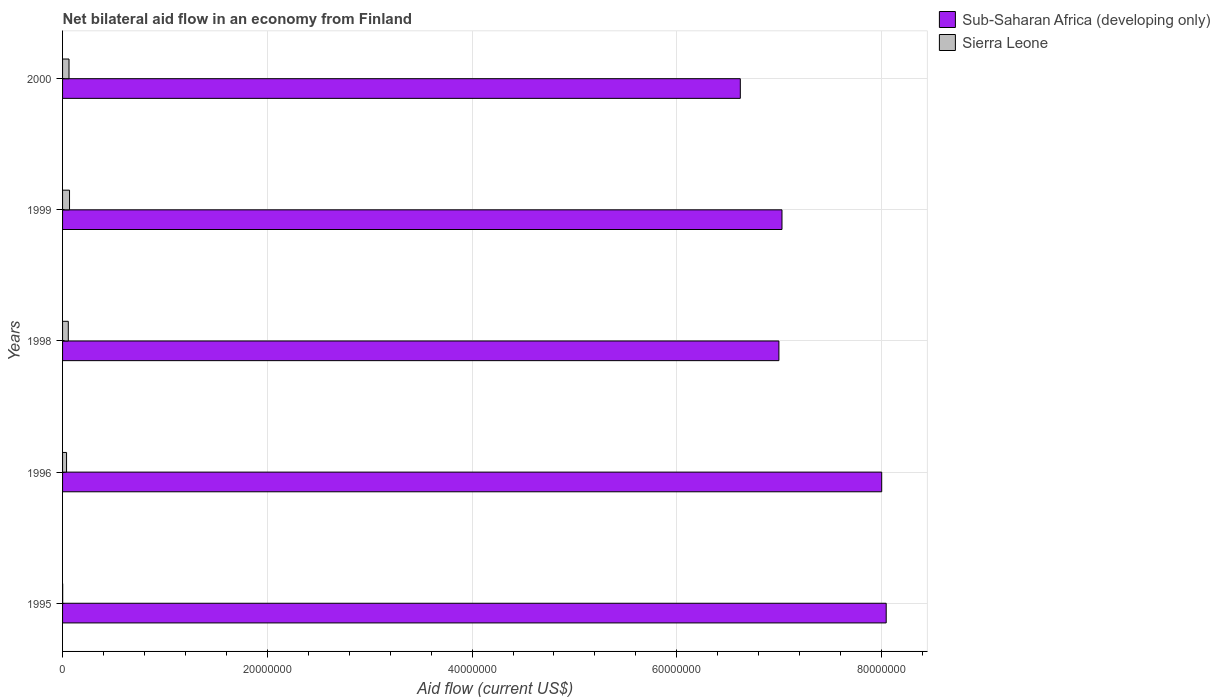How many different coloured bars are there?
Your answer should be very brief. 2. How many groups of bars are there?
Keep it short and to the point. 5. How many bars are there on the 4th tick from the bottom?
Offer a very short reply. 2. What is the net bilateral aid flow in Sub-Saharan Africa (developing only) in 1996?
Your answer should be very brief. 8.00e+07. Across all years, what is the maximum net bilateral aid flow in Sub-Saharan Africa (developing only)?
Your answer should be very brief. 8.04e+07. In which year was the net bilateral aid flow in Sierra Leone maximum?
Provide a succinct answer. 1999. What is the total net bilateral aid flow in Sub-Saharan Africa (developing only) in the graph?
Provide a succinct answer. 3.67e+08. What is the difference between the net bilateral aid flow in Sierra Leone in 1996 and the net bilateral aid flow in Sub-Saharan Africa (developing only) in 2000?
Your answer should be compact. -6.58e+07. What is the average net bilateral aid flow in Sierra Leone per year?
Make the answer very short. 4.54e+05. In the year 1998, what is the difference between the net bilateral aid flow in Sierra Leone and net bilateral aid flow in Sub-Saharan Africa (developing only)?
Offer a terse response. -6.94e+07. What is the ratio of the net bilateral aid flow in Sub-Saharan Africa (developing only) in 1999 to that in 2000?
Offer a terse response. 1.06. Is the difference between the net bilateral aid flow in Sierra Leone in 1995 and 1999 greater than the difference between the net bilateral aid flow in Sub-Saharan Africa (developing only) in 1995 and 1999?
Keep it short and to the point. No. What is the difference between the highest and the lowest net bilateral aid flow in Sub-Saharan Africa (developing only)?
Ensure brevity in your answer.  1.42e+07. In how many years, is the net bilateral aid flow in Sierra Leone greater than the average net bilateral aid flow in Sierra Leone taken over all years?
Make the answer very short. 3. What does the 1st bar from the top in 1996 represents?
Give a very brief answer. Sierra Leone. What does the 1st bar from the bottom in 1998 represents?
Your answer should be very brief. Sub-Saharan Africa (developing only). How many years are there in the graph?
Offer a terse response. 5. What is the difference between two consecutive major ticks on the X-axis?
Your answer should be very brief. 2.00e+07. Does the graph contain any zero values?
Make the answer very short. No. Does the graph contain grids?
Ensure brevity in your answer.  Yes. Where does the legend appear in the graph?
Keep it short and to the point. Top right. How many legend labels are there?
Provide a short and direct response. 2. What is the title of the graph?
Ensure brevity in your answer.  Net bilateral aid flow in an economy from Finland. What is the label or title of the X-axis?
Give a very brief answer. Aid flow (current US$). What is the Aid flow (current US$) in Sub-Saharan Africa (developing only) in 1995?
Make the answer very short. 8.04e+07. What is the Aid flow (current US$) of Sierra Leone in 1995?
Provide a short and direct response. 10000. What is the Aid flow (current US$) of Sub-Saharan Africa (developing only) in 1996?
Ensure brevity in your answer.  8.00e+07. What is the Aid flow (current US$) of Sierra Leone in 1996?
Give a very brief answer. 3.90e+05. What is the Aid flow (current US$) of Sub-Saharan Africa (developing only) in 1998?
Your answer should be compact. 7.00e+07. What is the Aid flow (current US$) in Sierra Leone in 1998?
Your response must be concise. 5.60e+05. What is the Aid flow (current US$) of Sub-Saharan Africa (developing only) in 1999?
Offer a very short reply. 7.03e+07. What is the Aid flow (current US$) in Sierra Leone in 1999?
Provide a succinct answer. 6.80e+05. What is the Aid flow (current US$) of Sub-Saharan Africa (developing only) in 2000?
Offer a very short reply. 6.62e+07. What is the Aid flow (current US$) of Sierra Leone in 2000?
Your answer should be very brief. 6.30e+05. Across all years, what is the maximum Aid flow (current US$) in Sub-Saharan Africa (developing only)?
Your response must be concise. 8.04e+07. Across all years, what is the maximum Aid flow (current US$) in Sierra Leone?
Make the answer very short. 6.80e+05. Across all years, what is the minimum Aid flow (current US$) in Sub-Saharan Africa (developing only)?
Make the answer very short. 6.62e+07. What is the total Aid flow (current US$) of Sub-Saharan Africa (developing only) in the graph?
Ensure brevity in your answer.  3.67e+08. What is the total Aid flow (current US$) in Sierra Leone in the graph?
Offer a very short reply. 2.27e+06. What is the difference between the Aid flow (current US$) in Sub-Saharan Africa (developing only) in 1995 and that in 1996?
Keep it short and to the point. 4.40e+05. What is the difference between the Aid flow (current US$) in Sierra Leone in 1995 and that in 1996?
Provide a short and direct response. -3.80e+05. What is the difference between the Aid flow (current US$) of Sub-Saharan Africa (developing only) in 1995 and that in 1998?
Ensure brevity in your answer.  1.05e+07. What is the difference between the Aid flow (current US$) of Sierra Leone in 1995 and that in 1998?
Make the answer very short. -5.50e+05. What is the difference between the Aid flow (current US$) in Sub-Saharan Africa (developing only) in 1995 and that in 1999?
Provide a short and direct response. 1.02e+07. What is the difference between the Aid flow (current US$) of Sierra Leone in 1995 and that in 1999?
Your response must be concise. -6.70e+05. What is the difference between the Aid flow (current US$) in Sub-Saharan Africa (developing only) in 1995 and that in 2000?
Provide a short and direct response. 1.42e+07. What is the difference between the Aid flow (current US$) in Sierra Leone in 1995 and that in 2000?
Ensure brevity in your answer.  -6.20e+05. What is the difference between the Aid flow (current US$) of Sub-Saharan Africa (developing only) in 1996 and that in 1998?
Give a very brief answer. 1.00e+07. What is the difference between the Aid flow (current US$) of Sub-Saharan Africa (developing only) in 1996 and that in 1999?
Keep it short and to the point. 9.74e+06. What is the difference between the Aid flow (current US$) in Sub-Saharan Africa (developing only) in 1996 and that in 2000?
Provide a succinct answer. 1.38e+07. What is the difference between the Aid flow (current US$) in Sierra Leone in 1996 and that in 2000?
Offer a very short reply. -2.40e+05. What is the difference between the Aid flow (current US$) of Sub-Saharan Africa (developing only) in 1998 and that in 2000?
Keep it short and to the point. 3.77e+06. What is the difference between the Aid flow (current US$) in Sub-Saharan Africa (developing only) in 1999 and that in 2000?
Provide a short and direct response. 4.07e+06. What is the difference between the Aid flow (current US$) of Sub-Saharan Africa (developing only) in 1995 and the Aid flow (current US$) of Sierra Leone in 1996?
Your answer should be compact. 8.01e+07. What is the difference between the Aid flow (current US$) in Sub-Saharan Africa (developing only) in 1995 and the Aid flow (current US$) in Sierra Leone in 1998?
Your answer should be compact. 7.99e+07. What is the difference between the Aid flow (current US$) in Sub-Saharan Africa (developing only) in 1995 and the Aid flow (current US$) in Sierra Leone in 1999?
Provide a short and direct response. 7.98e+07. What is the difference between the Aid flow (current US$) of Sub-Saharan Africa (developing only) in 1995 and the Aid flow (current US$) of Sierra Leone in 2000?
Ensure brevity in your answer.  7.98e+07. What is the difference between the Aid flow (current US$) of Sub-Saharan Africa (developing only) in 1996 and the Aid flow (current US$) of Sierra Leone in 1998?
Give a very brief answer. 7.94e+07. What is the difference between the Aid flow (current US$) in Sub-Saharan Africa (developing only) in 1996 and the Aid flow (current US$) in Sierra Leone in 1999?
Offer a terse response. 7.93e+07. What is the difference between the Aid flow (current US$) of Sub-Saharan Africa (developing only) in 1996 and the Aid flow (current US$) of Sierra Leone in 2000?
Keep it short and to the point. 7.94e+07. What is the difference between the Aid flow (current US$) of Sub-Saharan Africa (developing only) in 1998 and the Aid flow (current US$) of Sierra Leone in 1999?
Keep it short and to the point. 6.93e+07. What is the difference between the Aid flow (current US$) of Sub-Saharan Africa (developing only) in 1998 and the Aid flow (current US$) of Sierra Leone in 2000?
Provide a succinct answer. 6.93e+07. What is the difference between the Aid flow (current US$) in Sub-Saharan Africa (developing only) in 1999 and the Aid flow (current US$) in Sierra Leone in 2000?
Your response must be concise. 6.96e+07. What is the average Aid flow (current US$) of Sub-Saharan Africa (developing only) per year?
Offer a very short reply. 7.34e+07. What is the average Aid flow (current US$) in Sierra Leone per year?
Your response must be concise. 4.54e+05. In the year 1995, what is the difference between the Aid flow (current US$) in Sub-Saharan Africa (developing only) and Aid flow (current US$) in Sierra Leone?
Give a very brief answer. 8.04e+07. In the year 1996, what is the difference between the Aid flow (current US$) in Sub-Saharan Africa (developing only) and Aid flow (current US$) in Sierra Leone?
Offer a very short reply. 7.96e+07. In the year 1998, what is the difference between the Aid flow (current US$) of Sub-Saharan Africa (developing only) and Aid flow (current US$) of Sierra Leone?
Keep it short and to the point. 6.94e+07. In the year 1999, what is the difference between the Aid flow (current US$) in Sub-Saharan Africa (developing only) and Aid flow (current US$) in Sierra Leone?
Provide a short and direct response. 6.96e+07. In the year 2000, what is the difference between the Aid flow (current US$) of Sub-Saharan Africa (developing only) and Aid flow (current US$) of Sierra Leone?
Your answer should be very brief. 6.56e+07. What is the ratio of the Aid flow (current US$) in Sub-Saharan Africa (developing only) in 1995 to that in 1996?
Offer a terse response. 1.01. What is the ratio of the Aid flow (current US$) of Sierra Leone in 1995 to that in 1996?
Provide a short and direct response. 0.03. What is the ratio of the Aid flow (current US$) in Sub-Saharan Africa (developing only) in 1995 to that in 1998?
Give a very brief answer. 1.15. What is the ratio of the Aid flow (current US$) in Sierra Leone in 1995 to that in 1998?
Make the answer very short. 0.02. What is the ratio of the Aid flow (current US$) of Sub-Saharan Africa (developing only) in 1995 to that in 1999?
Your answer should be very brief. 1.14. What is the ratio of the Aid flow (current US$) in Sierra Leone in 1995 to that in 1999?
Provide a short and direct response. 0.01. What is the ratio of the Aid flow (current US$) in Sub-Saharan Africa (developing only) in 1995 to that in 2000?
Your response must be concise. 1.22. What is the ratio of the Aid flow (current US$) of Sierra Leone in 1995 to that in 2000?
Your answer should be compact. 0.02. What is the ratio of the Aid flow (current US$) of Sub-Saharan Africa (developing only) in 1996 to that in 1998?
Your answer should be compact. 1.14. What is the ratio of the Aid flow (current US$) of Sierra Leone in 1996 to that in 1998?
Your answer should be compact. 0.7. What is the ratio of the Aid flow (current US$) in Sub-Saharan Africa (developing only) in 1996 to that in 1999?
Your answer should be compact. 1.14. What is the ratio of the Aid flow (current US$) in Sierra Leone in 1996 to that in 1999?
Offer a very short reply. 0.57. What is the ratio of the Aid flow (current US$) of Sub-Saharan Africa (developing only) in 1996 to that in 2000?
Offer a terse response. 1.21. What is the ratio of the Aid flow (current US$) of Sierra Leone in 1996 to that in 2000?
Give a very brief answer. 0.62. What is the ratio of the Aid flow (current US$) of Sierra Leone in 1998 to that in 1999?
Provide a succinct answer. 0.82. What is the ratio of the Aid flow (current US$) of Sub-Saharan Africa (developing only) in 1998 to that in 2000?
Your response must be concise. 1.06. What is the ratio of the Aid flow (current US$) of Sub-Saharan Africa (developing only) in 1999 to that in 2000?
Offer a very short reply. 1.06. What is the ratio of the Aid flow (current US$) in Sierra Leone in 1999 to that in 2000?
Provide a succinct answer. 1.08. What is the difference between the highest and the second highest Aid flow (current US$) of Sub-Saharan Africa (developing only)?
Provide a short and direct response. 4.40e+05. What is the difference between the highest and the lowest Aid flow (current US$) of Sub-Saharan Africa (developing only)?
Your answer should be compact. 1.42e+07. What is the difference between the highest and the lowest Aid flow (current US$) in Sierra Leone?
Give a very brief answer. 6.70e+05. 